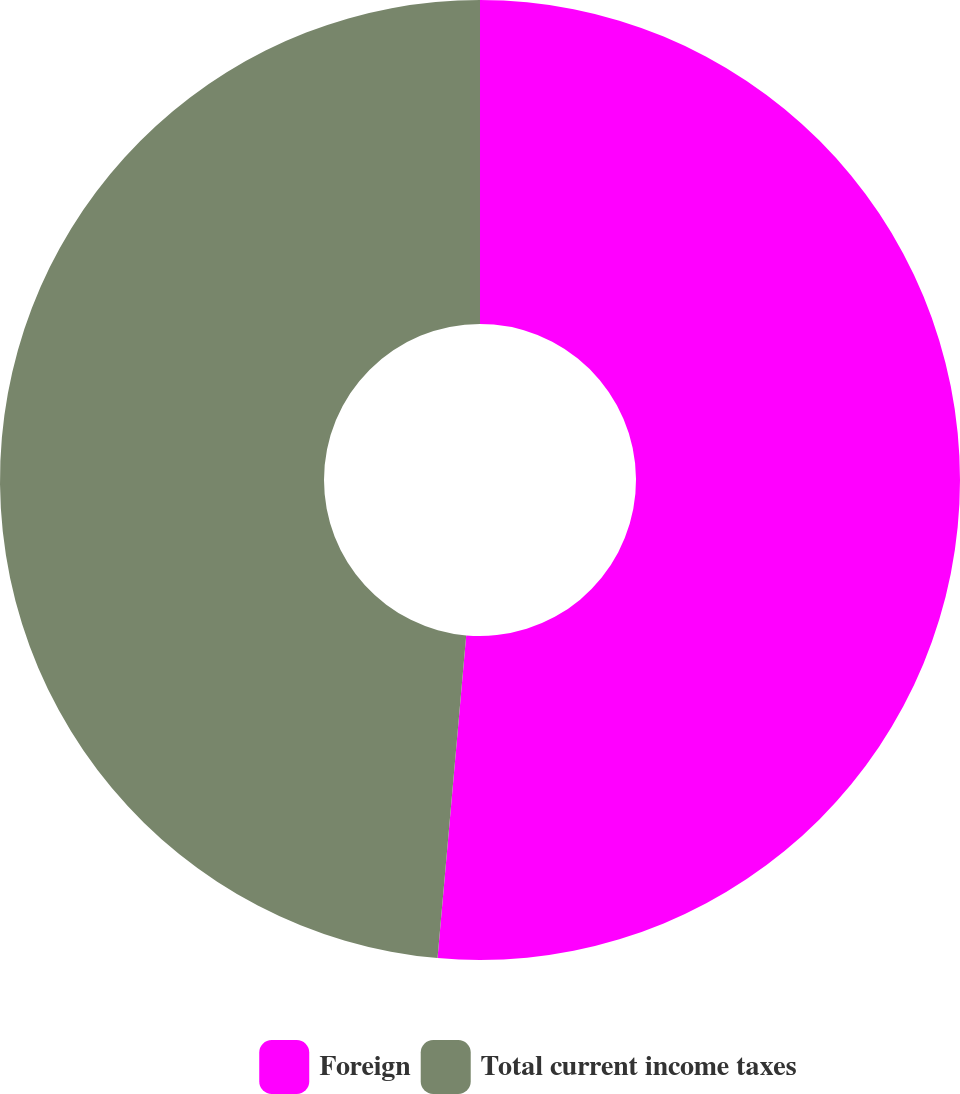Convert chart. <chart><loc_0><loc_0><loc_500><loc_500><pie_chart><fcel>Foreign<fcel>Total current income taxes<nl><fcel>51.41%<fcel>48.59%<nl></chart> 